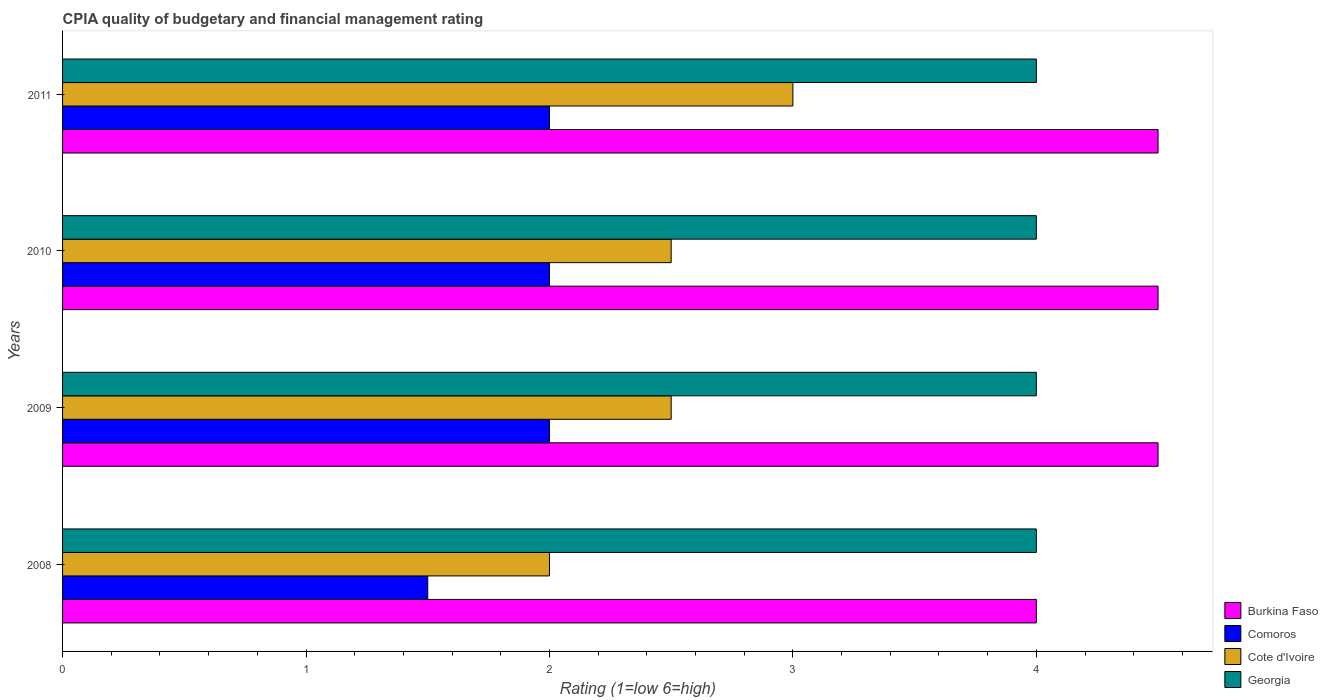Are the number of bars per tick equal to the number of legend labels?
Give a very brief answer. Yes. How many bars are there on the 3rd tick from the top?
Give a very brief answer. 4. How many bars are there on the 3rd tick from the bottom?
Give a very brief answer. 4. What is the label of the 4th group of bars from the top?
Provide a succinct answer. 2008. In how many cases, is the number of bars for a given year not equal to the number of legend labels?
Offer a very short reply. 0. What is the CPIA rating in Comoros in 2009?
Your response must be concise. 2. Across all years, what is the maximum CPIA rating in Georgia?
Make the answer very short. 4. In which year was the CPIA rating in Comoros maximum?
Offer a very short reply. 2009. In which year was the CPIA rating in Burkina Faso minimum?
Offer a very short reply. 2008. What is the total CPIA rating in Georgia in the graph?
Keep it short and to the point. 16. What is the average CPIA rating in Cote d'Ivoire per year?
Offer a very short reply. 2.5. In the year 2008, what is the difference between the CPIA rating in Cote d'Ivoire and CPIA rating in Comoros?
Ensure brevity in your answer.  0.5. What is the difference between the highest and the lowest CPIA rating in Cote d'Ivoire?
Ensure brevity in your answer.  1. Is it the case that in every year, the sum of the CPIA rating in Burkina Faso and CPIA rating in Cote d'Ivoire is greater than the sum of CPIA rating in Georgia and CPIA rating in Comoros?
Your response must be concise. Yes. What does the 4th bar from the top in 2009 represents?
Your response must be concise. Burkina Faso. What does the 4th bar from the bottom in 2011 represents?
Your response must be concise. Georgia. How many bars are there?
Provide a succinct answer. 16. Are all the bars in the graph horizontal?
Your answer should be compact. Yes. How many years are there in the graph?
Your answer should be compact. 4. What is the difference between two consecutive major ticks on the X-axis?
Make the answer very short. 1. Are the values on the major ticks of X-axis written in scientific E-notation?
Your response must be concise. No. Does the graph contain any zero values?
Give a very brief answer. No. Where does the legend appear in the graph?
Provide a short and direct response. Bottom right. How many legend labels are there?
Ensure brevity in your answer.  4. What is the title of the graph?
Make the answer very short. CPIA quality of budgetary and financial management rating. Does "Brazil" appear as one of the legend labels in the graph?
Offer a very short reply. No. What is the label or title of the Y-axis?
Provide a short and direct response. Years. What is the Rating (1=low 6=high) of Comoros in 2008?
Your answer should be compact. 1.5. What is the Rating (1=low 6=high) of Georgia in 2010?
Keep it short and to the point. 4. What is the Rating (1=low 6=high) in Burkina Faso in 2011?
Offer a terse response. 4.5. What is the Rating (1=low 6=high) of Comoros in 2011?
Provide a short and direct response. 2. What is the Rating (1=low 6=high) in Cote d'Ivoire in 2011?
Keep it short and to the point. 3. Across all years, what is the maximum Rating (1=low 6=high) in Burkina Faso?
Offer a very short reply. 4.5. Across all years, what is the maximum Rating (1=low 6=high) in Comoros?
Offer a very short reply. 2. Across all years, what is the minimum Rating (1=low 6=high) in Burkina Faso?
Your answer should be compact. 4. Across all years, what is the minimum Rating (1=low 6=high) of Comoros?
Ensure brevity in your answer.  1.5. Across all years, what is the minimum Rating (1=low 6=high) of Cote d'Ivoire?
Ensure brevity in your answer.  2. Across all years, what is the minimum Rating (1=low 6=high) of Georgia?
Offer a very short reply. 4. What is the total Rating (1=low 6=high) in Georgia in the graph?
Your response must be concise. 16. What is the difference between the Rating (1=low 6=high) of Comoros in 2008 and that in 2009?
Provide a short and direct response. -0.5. What is the difference between the Rating (1=low 6=high) of Cote d'Ivoire in 2008 and that in 2009?
Provide a succinct answer. -0.5. What is the difference between the Rating (1=low 6=high) in Georgia in 2008 and that in 2009?
Make the answer very short. 0. What is the difference between the Rating (1=low 6=high) in Burkina Faso in 2008 and that in 2010?
Keep it short and to the point. -0.5. What is the difference between the Rating (1=low 6=high) in Cote d'Ivoire in 2008 and that in 2010?
Your answer should be very brief. -0.5. What is the difference between the Rating (1=low 6=high) of Georgia in 2008 and that in 2010?
Offer a very short reply. 0. What is the difference between the Rating (1=low 6=high) in Comoros in 2008 and that in 2011?
Give a very brief answer. -0.5. What is the difference between the Rating (1=low 6=high) in Cote d'Ivoire in 2009 and that in 2010?
Offer a very short reply. 0. What is the difference between the Rating (1=low 6=high) of Burkina Faso in 2009 and that in 2011?
Make the answer very short. 0. What is the difference between the Rating (1=low 6=high) of Burkina Faso in 2010 and that in 2011?
Make the answer very short. 0. What is the difference between the Rating (1=low 6=high) of Burkina Faso in 2008 and the Rating (1=low 6=high) of Georgia in 2009?
Your response must be concise. 0. What is the difference between the Rating (1=low 6=high) in Comoros in 2008 and the Rating (1=low 6=high) in Georgia in 2009?
Offer a terse response. -2.5. What is the difference between the Rating (1=low 6=high) in Cote d'Ivoire in 2008 and the Rating (1=low 6=high) in Georgia in 2009?
Give a very brief answer. -2. What is the difference between the Rating (1=low 6=high) of Burkina Faso in 2008 and the Rating (1=low 6=high) of Georgia in 2010?
Provide a succinct answer. 0. What is the difference between the Rating (1=low 6=high) in Comoros in 2008 and the Rating (1=low 6=high) in Cote d'Ivoire in 2010?
Your answer should be very brief. -1. What is the difference between the Rating (1=low 6=high) of Comoros in 2008 and the Rating (1=low 6=high) of Georgia in 2010?
Your answer should be compact. -2.5. What is the difference between the Rating (1=low 6=high) of Burkina Faso in 2008 and the Rating (1=low 6=high) of Comoros in 2011?
Offer a terse response. 2. What is the difference between the Rating (1=low 6=high) in Comoros in 2008 and the Rating (1=low 6=high) in Cote d'Ivoire in 2011?
Keep it short and to the point. -1.5. What is the difference between the Rating (1=low 6=high) in Comoros in 2008 and the Rating (1=low 6=high) in Georgia in 2011?
Provide a succinct answer. -2.5. What is the difference between the Rating (1=low 6=high) in Cote d'Ivoire in 2008 and the Rating (1=low 6=high) in Georgia in 2011?
Your response must be concise. -2. What is the difference between the Rating (1=low 6=high) of Burkina Faso in 2009 and the Rating (1=low 6=high) of Comoros in 2010?
Your answer should be very brief. 2.5. What is the difference between the Rating (1=low 6=high) in Burkina Faso in 2009 and the Rating (1=low 6=high) in Georgia in 2010?
Provide a short and direct response. 0.5. What is the difference between the Rating (1=low 6=high) in Cote d'Ivoire in 2009 and the Rating (1=low 6=high) in Georgia in 2010?
Offer a very short reply. -1.5. What is the difference between the Rating (1=low 6=high) of Burkina Faso in 2009 and the Rating (1=low 6=high) of Comoros in 2011?
Provide a short and direct response. 2.5. What is the difference between the Rating (1=low 6=high) in Comoros in 2009 and the Rating (1=low 6=high) in Cote d'Ivoire in 2011?
Make the answer very short. -1. What is the difference between the Rating (1=low 6=high) of Comoros in 2009 and the Rating (1=low 6=high) of Georgia in 2011?
Offer a very short reply. -2. What is the difference between the Rating (1=low 6=high) of Cote d'Ivoire in 2009 and the Rating (1=low 6=high) of Georgia in 2011?
Make the answer very short. -1.5. What is the difference between the Rating (1=low 6=high) in Comoros in 2010 and the Rating (1=low 6=high) in Georgia in 2011?
Provide a succinct answer. -2. What is the average Rating (1=low 6=high) of Burkina Faso per year?
Your answer should be compact. 4.38. What is the average Rating (1=low 6=high) in Comoros per year?
Keep it short and to the point. 1.88. What is the average Rating (1=low 6=high) of Cote d'Ivoire per year?
Make the answer very short. 2.5. In the year 2008, what is the difference between the Rating (1=low 6=high) in Comoros and Rating (1=low 6=high) in Cote d'Ivoire?
Your answer should be compact. -0.5. In the year 2008, what is the difference between the Rating (1=low 6=high) in Cote d'Ivoire and Rating (1=low 6=high) in Georgia?
Provide a short and direct response. -2. In the year 2009, what is the difference between the Rating (1=low 6=high) of Burkina Faso and Rating (1=low 6=high) of Cote d'Ivoire?
Your response must be concise. 2. In the year 2009, what is the difference between the Rating (1=low 6=high) of Burkina Faso and Rating (1=low 6=high) of Georgia?
Provide a succinct answer. 0.5. In the year 2009, what is the difference between the Rating (1=low 6=high) of Cote d'Ivoire and Rating (1=low 6=high) of Georgia?
Ensure brevity in your answer.  -1.5. In the year 2010, what is the difference between the Rating (1=low 6=high) of Burkina Faso and Rating (1=low 6=high) of Comoros?
Offer a terse response. 2.5. In the year 2010, what is the difference between the Rating (1=low 6=high) in Burkina Faso and Rating (1=low 6=high) in Georgia?
Make the answer very short. 0.5. In the year 2010, what is the difference between the Rating (1=low 6=high) in Comoros and Rating (1=low 6=high) in Cote d'Ivoire?
Offer a very short reply. -0.5. In the year 2011, what is the difference between the Rating (1=low 6=high) in Burkina Faso and Rating (1=low 6=high) in Comoros?
Ensure brevity in your answer.  2.5. In the year 2011, what is the difference between the Rating (1=low 6=high) of Burkina Faso and Rating (1=low 6=high) of Cote d'Ivoire?
Ensure brevity in your answer.  1.5. In the year 2011, what is the difference between the Rating (1=low 6=high) of Comoros and Rating (1=low 6=high) of Cote d'Ivoire?
Your response must be concise. -1. In the year 2011, what is the difference between the Rating (1=low 6=high) of Comoros and Rating (1=low 6=high) of Georgia?
Your answer should be very brief. -2. What is the ratio of the Rating (1=low 6=high) in Burkina Faso in 2008 to that in 2009?
Keep it short and to the point. 0.89. What is the ratio of the Rating (1=low 6=high) of Comoros in 2008 to that in 2009?
Provide a short and direct response. 0.75. What is the ratio of the Rating (1=low 6=high) in Cote d'Ivoire in 2008 to that in 2009?
Make the answer very short. 0.8. What is the ratio of the Rating (1=low 6=high) of Comoros in 2008 to that in 2010?
Offer a very short reply. 0.75. What is the ratio of the Rating (1=low 6=high) in Burkina Faso in 2008 to that in 2011?
Your answer should be very brief. 0.89. What is the ratio of the Rating (1=low 6=high) in Burkina Faso in 2009 to that in 2011?
Ensure brevity in your answer.  1. What is the ratio of the Rating (1=low 6=high) in Georgia in 2009 to that in 2011?
Provide a succinct answer. 1. What is the ratio of the Rating (1=low 6=high) of Comoros in 2010 to that in 2011?
Make the answer very short. 1. What is the ratio of the Rating (1=low 6=high) of Cote d'Ivoire in 2010 to that in 2011?
Offer a very short reply. 0.83. What is the difference between the highest and the second highest Rating (1=low 6=high) in Comoros?
Your response must be concise. 0. What is the difference between the highest and the second highest Rating (1=low 6=high) in Georgia?
Provide a short and direct response. 0. What is the difference between the highest and the lowest Rating (1=low 6=high) of Burkina Faso?
Your response must be concise. 0.5. What is the difference between the highest and the lowest Rating (1=low 6=high) of Cote d'Ivoire?
Your answer should be very brief. 1. 